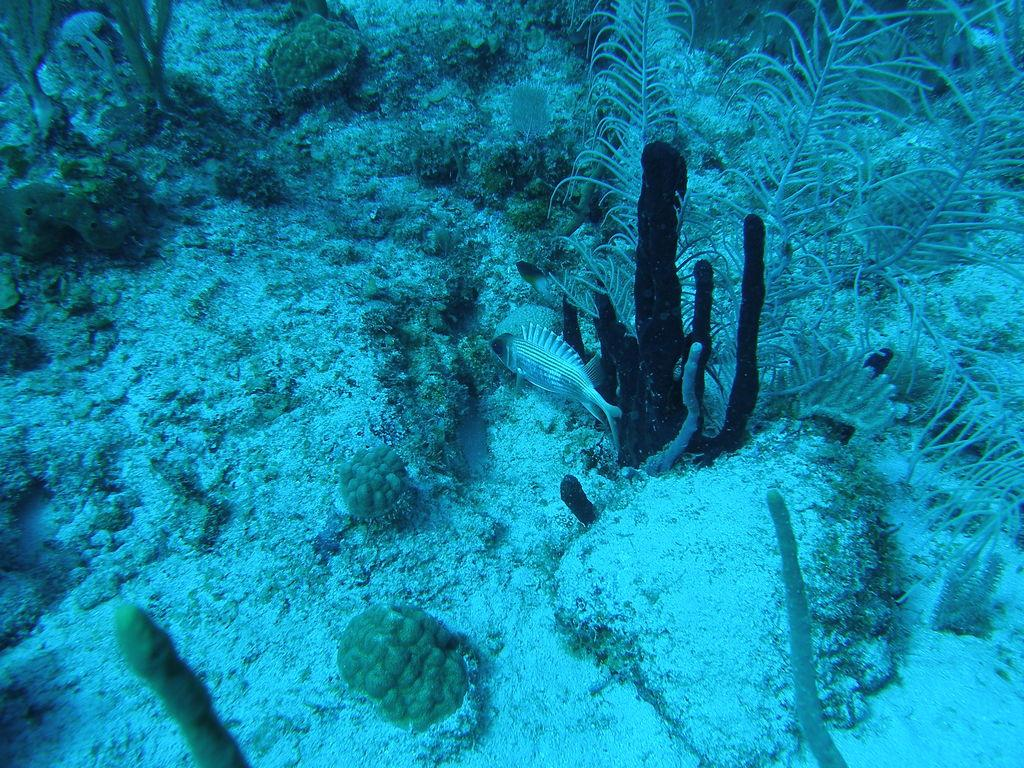What is the setting of the image? The image is taken underwater. What types of plants can be seen in the image? There are water plants in the image. What other living organisms are present in the image? There are fishes in the image. What type of linen is being used for the party in the image? There is no linen or party present in the image; it is an underwater scene with water plants and fishes. 